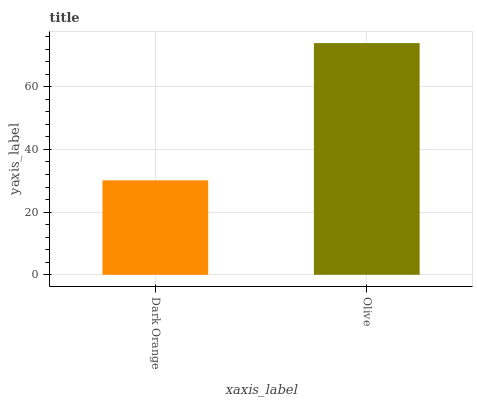Is Dark Orange the minimum?
Answer yes or no. Yes. Is Olive the maximum?
Answer yes or no. Yes. Is Olive the minimum?
Answer yes or no. No. Is Olive greater than Dark Orange?
Answer yes or no. Yes. Is Dark Orange less than Olive?
Answer yes or no. Yes. Is Dark Orange greater than Olive?
Answer yes or no. No. Is Olive less than Dark Orange?
Answer yes or no. No. Is Olive the high median?
Answer yes or no. Yes. Is Dark Orange the low median?
Answer yes or no. Yes. Is Dark Orange the high median?
Answer yes or no. No. Is Olive the low median?
Answer yes or no. No. 